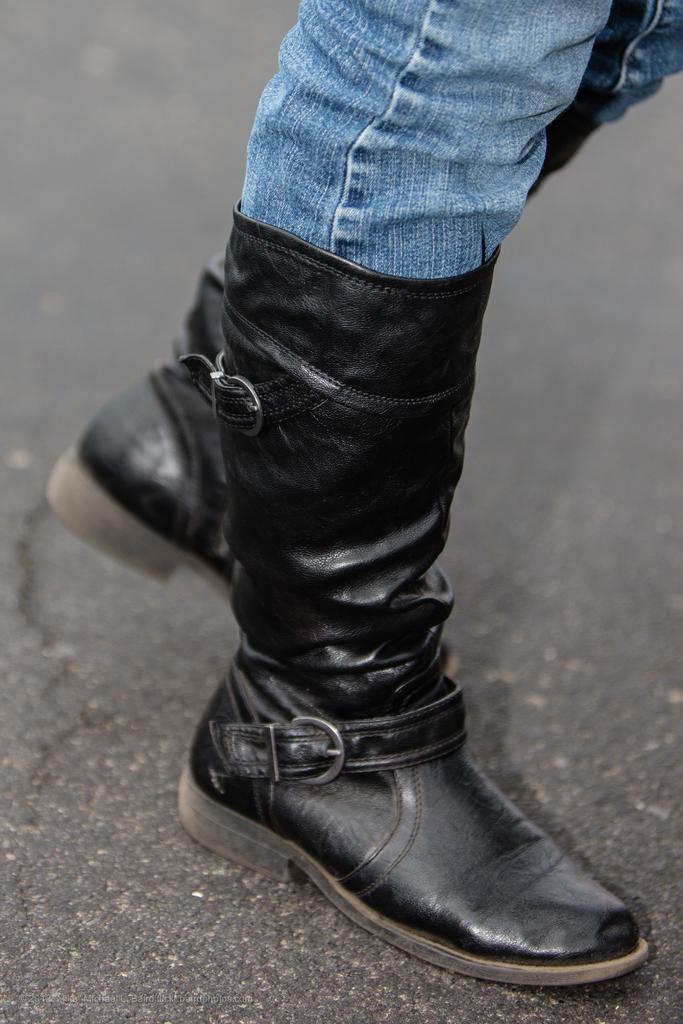How would you summarize this image in a sentence or two? In this image we can see one person's legs in jeans with black boots on the road. 